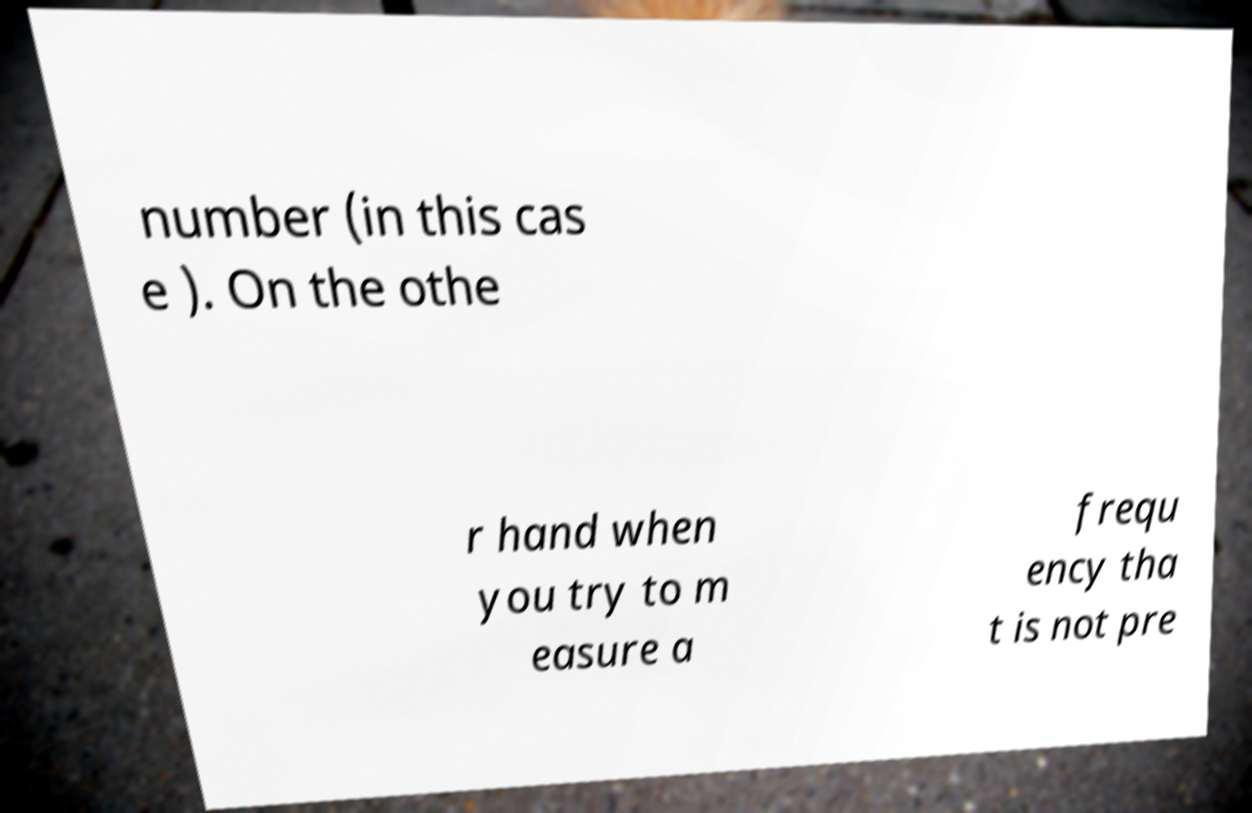For documentation purposes, I need the text within this image transcribed. Could you provide that? number (in this cas e ). On the othe r hand when you try to m easure a frequ ency tha t is not pre 